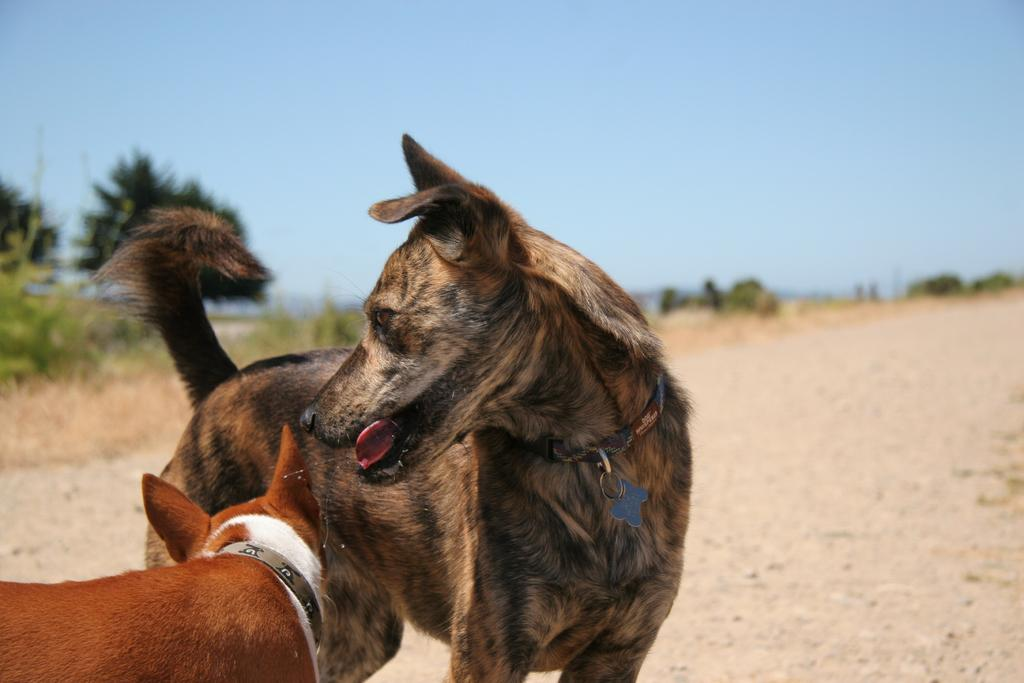How many dogs are in the image? There are two dogs standing in the image. What are the dogs wearing? The dogs appear to be wearing belts. What can be seen in the background of the image? There are trees and plants in the background of the image. What is visible in the sky in the image? The sky is visible in the image. Are there any wood structures visible in the image? There is no wood structure present in the image; it features two dogs standing in front of trees and plants. Can you see any fairies interacting with the dogs in the image? There are no fairies present in the image; it only features two dogs and the surrounding environment. 